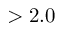Convert formula to latex. <formula><loc_0><loc_0><loc_500><loc_500>> 2 . 0</formula> 